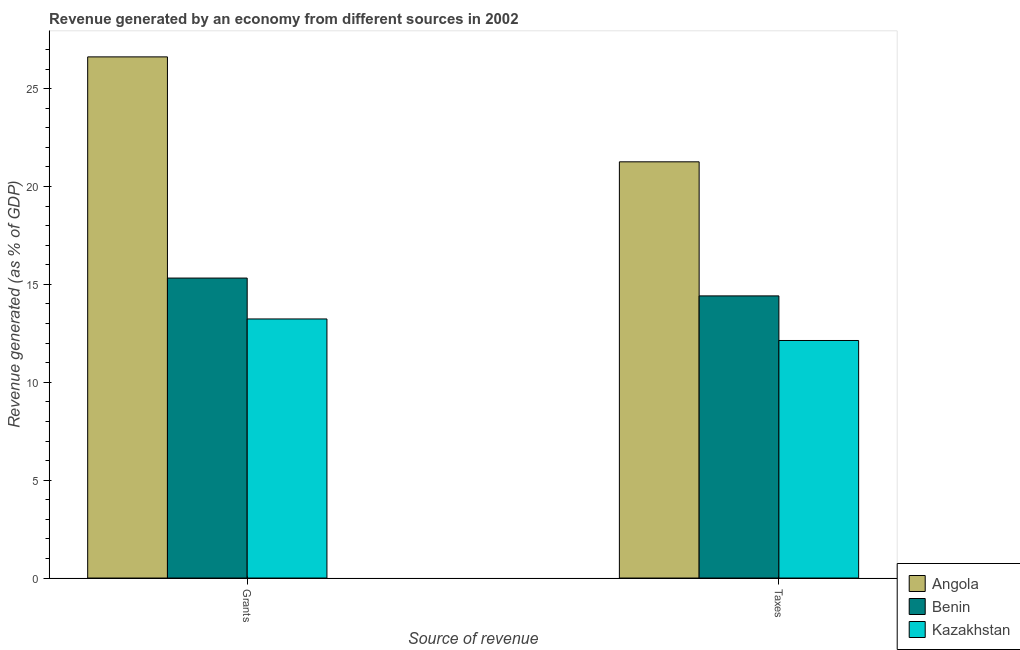Are the number of bars on each tick of the X-axis equal?
Keep it short and to the point. Yes. How many bars are there on the 2nd tick from the left?
Provide a succinct answer. 3. How many bars are there on the 2nd tick from the right?
Your answer should be compact. 3. What is the label of the 1st group of bars from the left?
Make the answer very short. Grants. What is the revenue generated by grants in Angola?
Provide a short and direct response. 26.62. Across all countries, what is the maximum revenue generated by taxes?
Offer a terse response. 21.26. Across all countries, what is the minimum revenue generated by grants?
Your answer should be compact. 13.23. In which country was the revenue generated by grants maximum?
Make the answer very short. Angola. In which country was the revenue generated by taxes minimum?
Give a very brief answer. Kazakhstan. What is the total revenue generated by taxes in the graph?
Keep it short and to the point. 47.81. What is the difference between the revenue generated by grants in Angola and that in Kazakhstan?
Provide a succinct answer. 13.39. What is the difference between the revenue generated by taxes in Angola and the revenue generated by grants in Benin?
Your answer should be very brief. 5.94. What is the average revenue generated by grants per country?
Make the answer very short. 18.39. What is the difference between the revenue generated by taxes and revenue generated by grants in Angola?
Provide a succinct answer. -5.36. In how many countries, is the revenue generated by grants greater than 3 %?
Offer a terse response. 3. What is the ratio of the revenue generated by grants in Angola to that in Kazakhstan?
Your answer should be very brief. 2.01. In how many countries, is the revenue generated by grants greater than the average revenue generated by grants taken over all countries?
Provide a succinct answer. 1. What does the 2nd bar from the left in Grants represents?
Your response must be concise. Benin. What does the 1st bar from the right in Grants represents?
Provide a short and direct response. Kazakhstan. How many bars are there?
Your answer should be very brief. 6. What is the difference between two consecutive major ticks on the Y-axis?
Give a very brief answer. 5. Where does the legend appear in the graph?
Your answer should be compact. Bottom right. What is the title of the graph?
Your answer should be compact. Revenue generated by an economy from different sources in 2002. Does "South Africa" appear as one of the legend labels in the graph?
Ensure brevity in your answer.  No. What is the label or title of the X-axis?
Make the answer very short. Source of revenue. What is the label or title of the Y-axis?
Offer a very short reply. Revenue generated (as % of GDP). What is the Revenue generated (as % of GDP) in Angola in Grants?
Keep it short and to the point. 26.62. What is the Revenue generated (as % of GDP) of Benin in Grants?
Your answer should be compact. 15.32. What is the Revenue generated (as % of GDP) in Kazakhstan in Grants?
Offer a very short reply. 13.23. What is the Revenue generated (as % of GDP) of Angola in Taxes?
Make the answer very short. 21.26. What is the Revenue generated (as % of GDP) in Benin in Taxes?
Keep it short and to the point. 14.41. What is the Revenue generated (as % of GDP) in Kazakhstan in Taxes?
Keep it short and to the point. 12.13. Across all Source of revenue, what is the maximum Revenue generated (as % of GDP) of Angola?
Provide a short and direct response. 26.62. Across all Source of revenue, what is the maximum Revenue generated (as % of GDP) of Benin?
Keep it short and to the point. 15.32. Across all Source of revenue, what is the maximum Revenue generated (as % of GDP) in Kazakhstan?
Ensure brevity in your answer.  13.23. Across all Source of revenue, what is the minimum Revenue generated (as % of GDP) in Angola?
Offer a terse response. 21.26. Across all Source of revenue, what is the minimum Revenue generated (as % of GDP) in Benin?
Provide a succinct answer. 14.41. Across all Source of revenue, what is the minimum Revenue generated (as % of GDP) of Kazakhstan?
Offer a very short reply. 12.13. What is the total Revenue generated (as % of GDP) in Angola in the graph?
Your response must be concise. 47.88. What is the total Revenue generated (as % of GDP) in Benin in the graph?
Ensure brevity in your answer.  29.74. What is the total Revenue generated (as % of GDP) in Kazakhstan in the graph?
Make the answer very short. 25.37. What is the difference between the Revenue generated (as % of GDP) of Angola in Grants and that in Taxes?
Ensure brevity in your answer.  5.36. What is the difference between the Revenue generated (as % of GDP) in Benin in Grants and that in Taxes?
Your answer should be compact. 0.91. What is the difference between the Revenue generated (as % of GDP) in Angola in Grants and the Revenue generated (as % of GDP) in Benin in Taxes?
Your response must be concise. 12.21. What is the difference between the Revenue generated (as % of GDP) in Angola in Grants and the Revenue generated (as % of GDP) in Kazakhstan in Taxes?
Your response must be concise. 14.49. What is the difference between the Revenue generated (as % of GDP) in Benin in Grants and the Revenue generated (as % of GDP) in Kazakhstan in Taxes?
Your answer should be compact. 3.19. What is the average Revenue generated (as % of GDP) of Angola per Source of revenue?
Offer a very short reply. 23.94. What is the average Revenue generated (as % of GDP) in Benin per Source of revenue?
Your response must be concise. 14.87. What is the average Revenue generated (as % of GDP) of Kazakhstan per Source of revenue?
Offer a terse response. 12.68. What is the difference between the Revenue generated (as % of GDP) in Angola and Revenue generated (as % of GDP) in Benin in Grants?
Provide a succinct answer. 11.3. What is the difference between the Revenue generated (as % of GDP) in Angola and Revenue generated (as % of GDP) in Kazakhstan in Grants?
Your answer should be compact. 13.39. What is the difference between the Revenue generated (as % of GDP) of Benin and Revenue generated (as % of GDP) of Kazakhstan in Grants?
Provide a succinct answer. 2.09. What is the difference between the Revenue generated (as % of GDP) of Angola and Revenue generated (as % of GDP) of Benin in Taxes?
Your response must be concise. 6.85. What is the difference between the Revenue generated (as % of GDP) in Angola and Revenue generated (as % of GDP) in Kazakhstan in Taxes?
Make the answer very short. 9.13. What is the difference between the Revenue generated (as % of GDP) of Benin and Revenue generated (as % of GDP) of Kazakhstan in Taxes?
Keep it short and to the point. 2.28. What is the ratio of the Revenue generated (as % of GDP) of Angola in Grants to that in Taxes?
Provide a succinct answer. 1.25. What is the ratio of the Revenue generated (as % of GDP) in Benin in Grants to that in Taxes?
Give a very brief answer. 1.06. What is the ratio of the Revenue generated (as % of GDP) of Kazakhstan in Grants to that in Taxes?
Provide a succinct answer. 1.09. What is the difference between the highest and the second highest Revenue generated (as % of GDP) of Angola?
Your response must be concise. 5.36. What is the difference between the highest and the second highest Revenue generated (as % of GDP) in Benin?
Keep it short and to the point. 0.91. What is the difference between the highest and the second highest Revenue generated (as % of GDP) in Kazakhstan?
Your answer should be very brief. 1.1. What is the difference between the highest and the lowest Revenue generated (as % of GDP) in Angola?
Offer a terse response. 5.36. What is the difference between the highest and the lowest Revenue generated (as % of GDP) of Benin?
Offer a very short reply. 0.91. What is the difference between the highest and the lowest Revenue generated (as % of GDP) of Kazakhstan?
Give a very brief answer. 1.1. 